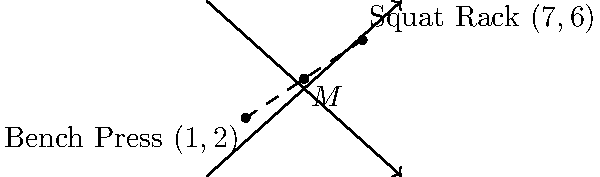In your gym layout, you've placed a bench press at coordinates $(1,2)$ and a squat rack at $(7,6)$. To maximize space efficiency, you want to place a water fountain exactly halfway between these two pieces of equipment. What are the coordinates of the point where you should install the water fountain? To find the midpoint of a line segment connecting two points, we can use the midpoint formula:

$$(x_M, y_M) = (\frac{x_1 + x_2}{2}, \frac{y_1 + y_2}{2})$$

Where $(x_1, y_1)$ are the coordinates of the first point and $(x_2, y_2)$ are the coordinates of the second point.

Given:
- Bench press coordinates: $(1,2)$
- Squat rack coordinates: $(7,6)$

Step 1: Calculate the x-coordinate of the midpoint:
$$x_M = \frac{x_1 + x_2}{2} = \frac{1 + 7}{2} = \frac{8}{2} = 4$$

Step 2: Calculate the y-coordinate of the midpoint:
$$y_M = \frac{y_1 + y_2}{2} = \frac{2 + 6}{2} = \frac{8}{2} = 4$$

Therefore, the coordinates of the midpoint where the water fountain should be installed are $(4,4)$.
Answer: $(4,4)$ 